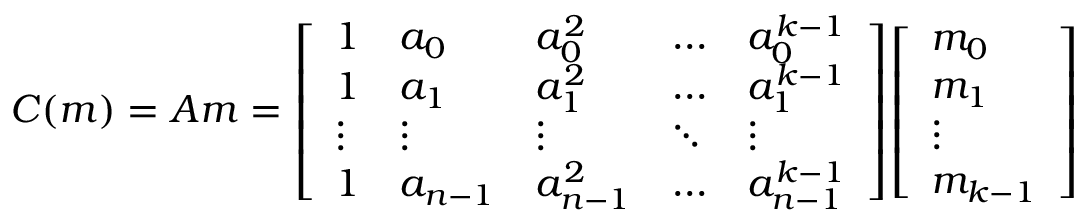<formula> <loc_0><loc_0><loc_500><loc_500>C ( m ) = A m = { \left [ \begin{array} { l l l l l } { 1 } & { a _ { 0 } } & { a _ { 0 } ^ { 2 } } & { \dots } & { a _ { 0 } ^ { k - 1 } } \\ { 1 } & { a _ { 1 } } & { a _ { 1 } ^ { 2 } } & { \dots } & { a _ { 1 } ^ { k - 1 } } \\ { \vdots } & { \vdots } & { \vdots } & { \ddots } & { \vdots } \\ { 1 } & { a _ { n - 1 } } & { a _ { n - 1 } ^ { 2 } } & { \dots } & { a _ { n - 1 } ^ { k - 1 } } \end{array} \right ] } { \left [ \begin{array} { l } { m _ { 0 } } \\ { m _ { 1 } } \\ { \vdots } \\ { m _ { k - 1 } } \end{array} \right ] }</formula> 